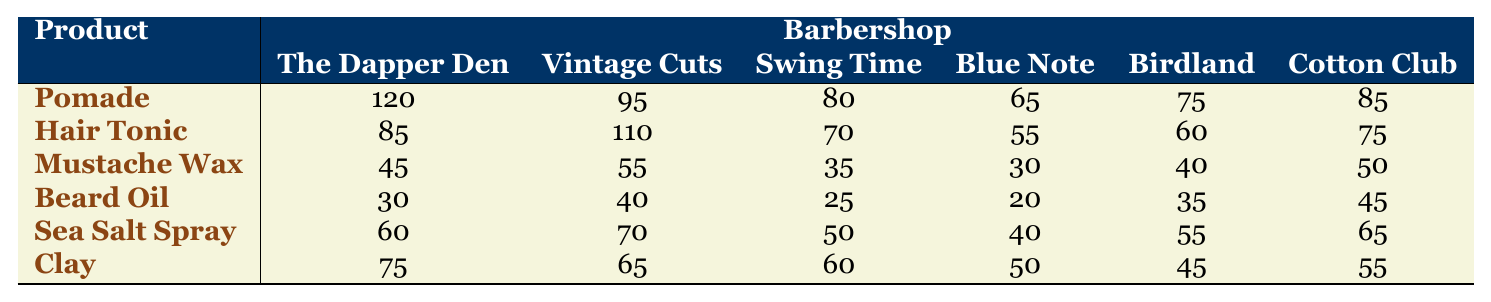What are the total sales of the Pomade across all barbershops? To find the total sales of Pomade, we add the sales figures for Pomade from each barbershop: 120 + 95 + 80 + 65 + 75 + 85 = 520.
Answer: 520 Which barbershop sold the highest amount of Hair Tonic? Looking at the sales figures for Hair Tonic, we see that Vintage Cuts & Co. has the highest sales of 110.
Answer: Vintage Cuts & Co What is the average sales of Mustache Wax across all barbershops? We sum the sales of Mustache Wax from each barbershop: 45 + 55 + 35 + 30 + 40 + 50 = 255. Then, we divide by the number of barbershops (6): 255 / 6 = 42.5.
Answer: 42.5 Did Swing Time Barbers sell more Beard Oil than Blue Note Grooming? The sales figure for Beard Oil at Swing Time is 25 and for Blue Note, it is 20. Since 25 is greater than 20, we can confirm that Swing Time Barbers sold more Beard Oil.
Answer: Yes What is the difference in sales between the top two barbershops for Sea Salt Spray? The top two sales figures for Sea Salt Spray are from Cotton Club Clippers (65) and Vintage Cuts & Co. (70). To find the difference, we subtract: 70 - 65 = 5.
Answer: 5 Which product had the least sales in total across all barbershops? We calculate the total sales for each product: Mustache Wax = 225, Beard Oil = 165, Clay = 335, Sea Salt Spray = 275, Hair Tonic = 455, and Pomade = 520. The least is Beard Oil with 165 sales.
Answer: Beard Oil What percentage of the total sales of Clay did The Dapper Den contribute? The total sales of Clay is 335, and The Dapper Den sold 75. To find the percentage contributed: (75 / 335) * 100 = approximately 22.39%.
Answer: 22.39% Which barbershop had the least overall sales? We calculate the total sales for each barbershop: The Dapper Den = 520, Vintage Cuts & Co. = 495, Swing Time = 340, Blue Note = 280, Birdland = 305, Cotton Club = 450. The least total sales is from Blue Note Grooming.
Answer: Blue Note Grooming What was the total sales for Sea Salt Spray in January? Looking at the sales figures, Sea Salt Spray had sales of 60 in January.
Answer: 60 Which product sold better, Hair Tonic or Beard Oil? Total sales of Hair Tonic are 455 and for Beard Oil it is 165. Since 455 is greater than 165, Hair Tonic sold better than Beard Oil.
Answer: Hair Tonic 